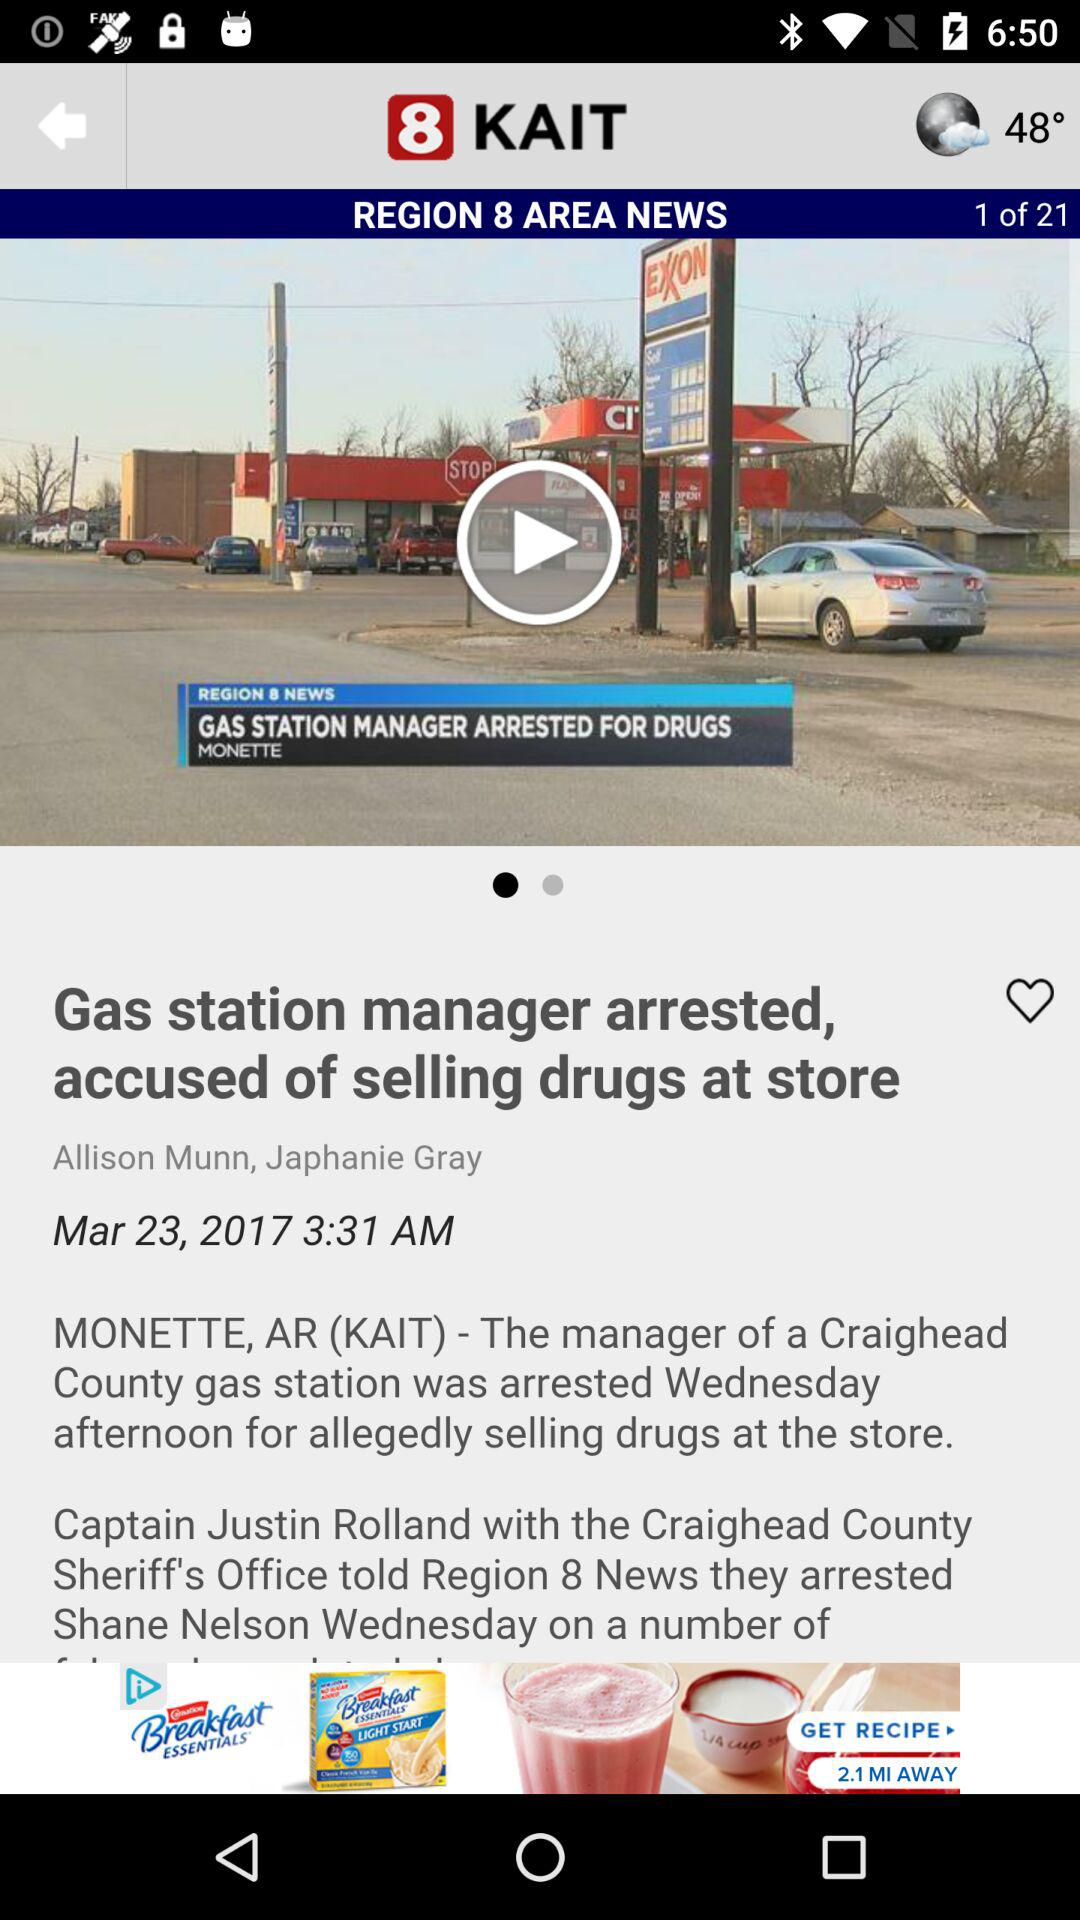What is the title of the article? The title is "REGION 8 AREA NEWS". 